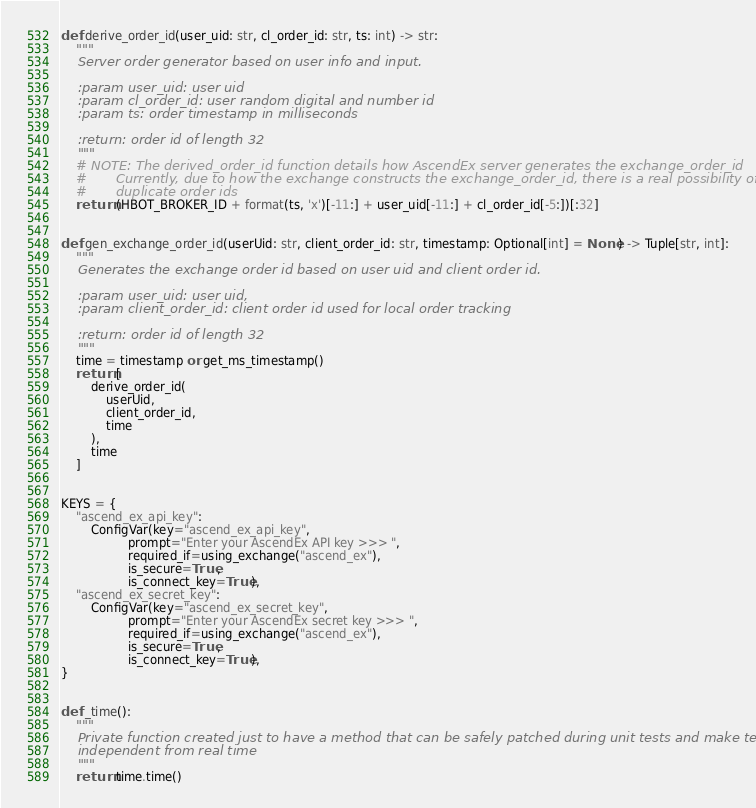<code> <loc_0><loc_0><loc_500><loc_500><_Python_>def derive_order_id(user_uid: str, cl_order_id: str, ts: int) -> str:
    """
    Server order generator based on user info and input.

    :param user_uid: user uid
    :param cl_order_id: user random digital and number id
    :param ts: order timestamp in milliseconds

    :return: order id of length 32
    """
    # NOTE: The derived_order_id function details how AscendEx server generates the exchange_order_id
    #       Currently, due to how the exchange constructs the exchange_order_id, there is a real possibility of
    #       duplicate order ids
    return (HBOT_BROKER_ID + format(ts, 'x')[-11:] + user_uid[-11:] + cl_order_id[-5:])[:32]


def gen_exchange_order_id(userUid: str, client_order_id: str, timestamp: Optional[int] = None) -> Tuple[str, int]:
    """
    Generates the exchange order id based on user uid and client order id.

    :param user_uid: user uid,
    :param client_order_id: client order id used for local order tracking

    :return: order id of length 32
    """
    time = timestamp or get_ms_timestamp()
    return [
        derive_order_id(
            userUid,
            client_order_id,
            time
        ),
        time
    ]


KEYS = {
    "ascend_ex_api_key":
        ConfigVar(key="ascend_ex_api_key",
                  prompt="Enter your AscendEx API key >>> ",
                  required_if=using_exchange("ascend_ex"),
                  is_secure=True,
                  is_connect_key=True),
    "ascend_ex_secret_key":
        ConfigVar(key="ascend_ex_secret_key",
                  prompt="Enter your AscendEx secret key >>> ",
                  required_if=using_exchange("ascend_ex"),
                  is_secure=True,
                  is_connect_key=True),
}


def _time():
    """
    Private function created just to have a method that can be safely patched during unit tests and make tests
    independent from real time
    """
    return time.time()
</code> 